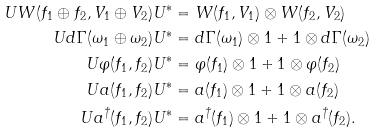<formula> <loc_0><loc_0><loc_500><loc_500>U W ( f _ { 1 } \oplus f _ { 2 } , V _ { 1 } \oplus V _ { 2 } ) U ^ { * } & = W ( f _ { 1 } , V _ { 1 } ) \otimes W ( f _ { 2 } , V _ { 2 } ) \\ U d \Gamma ( \omega _ { 1 } \oplus \omega _ { 2 } ) U ^ { * } & = d \Gamma ( \omega _ { 1 } ) \otimes 1 + 1 \otimes d \Gamma ( \omega _ { 2 } ) \\ U \varphi ( f _ { 1 } , f _ { 2 } ) U ^ { * } & = \varphi ( f _ { 1 } ) \otimes 1 + 1 \otimes \varphi ( f _ { 2 } ) \\ U a ( f _ { 1 } , f _ { 2 } ) U ^ { * } & = a ( f _ { 1 } ) \otimes 1 + 1 \otimes a ( f _ { 2 } ) \\ U a ^ { \dagger } ( f _ { 1 } , f _ { 2 } ) U ^ { * } & = a ^ { \dagger } ( f _ { 1 } ) \otimes 1 + 1 \otimes a ^ { \dagger } ( f _ { 2 } ) .</formula> 